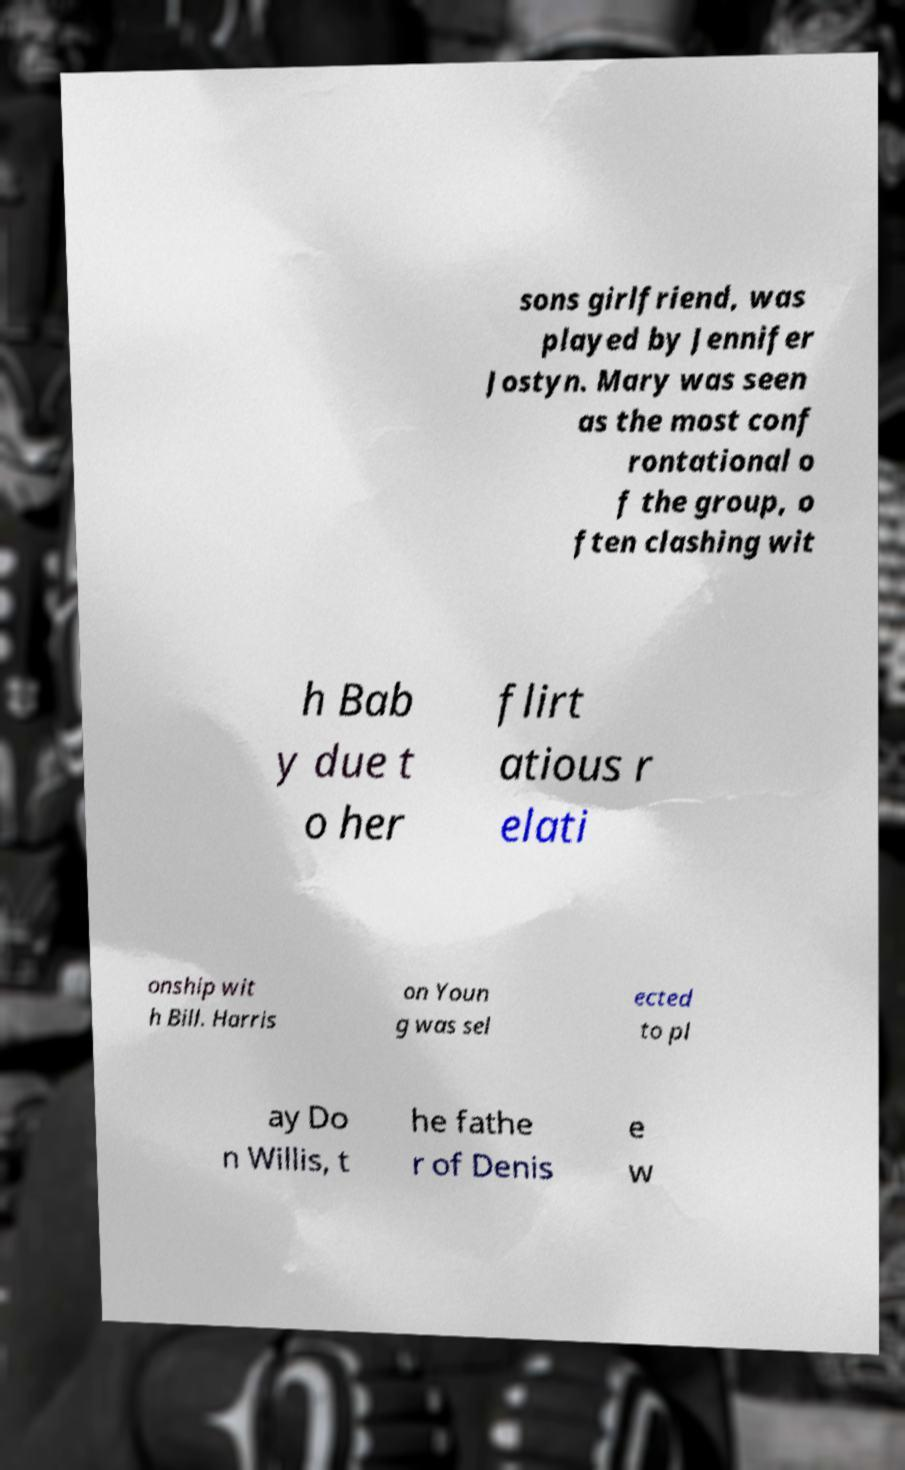What messages or text are displayed in this image? I need them in a readable, typed format. sons girlfriend, was played by Jennifer Jostyn. Mary was seen as the most conf rontational o f the group, o ften clashing wit h Bab y due t o her flirt atious r elati onship wit h Bill. Harris on Youn g was sel ected to pl ay Do n Willis, t he fathe r of Denis e w 